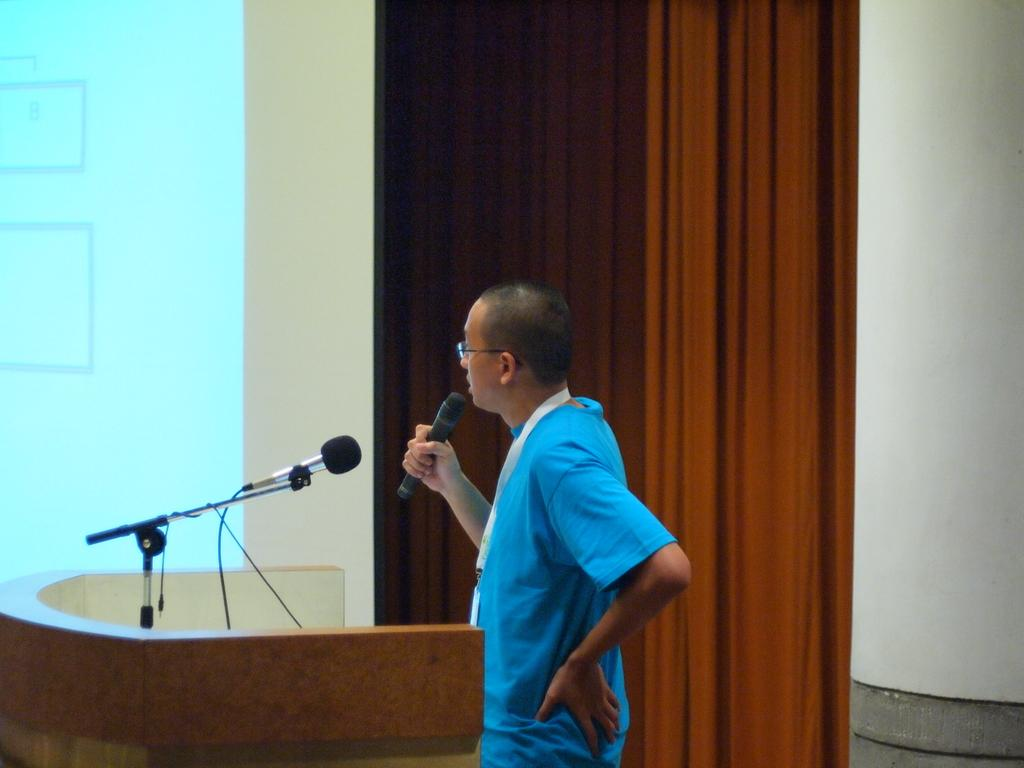What is the main subject of the image? The main subject of the image is a man. Can you describe the man's appearance? The man is wearing spectacles. What is the man holding in his hand? The man is holding a mic in his hand. Where is the man standing in the image? The man is standing at a podium with a mic on it. What can be seen in the background of the image? There is a screen visible in the background of the image. Is the man wearing a veil in the image? No, the man is not wearing a veil in the image; he is wearing spectacles. How many cents are visible on the screen in the background? There are no cents visible on the screen in the background; it is not mentioned in the provided facts. 